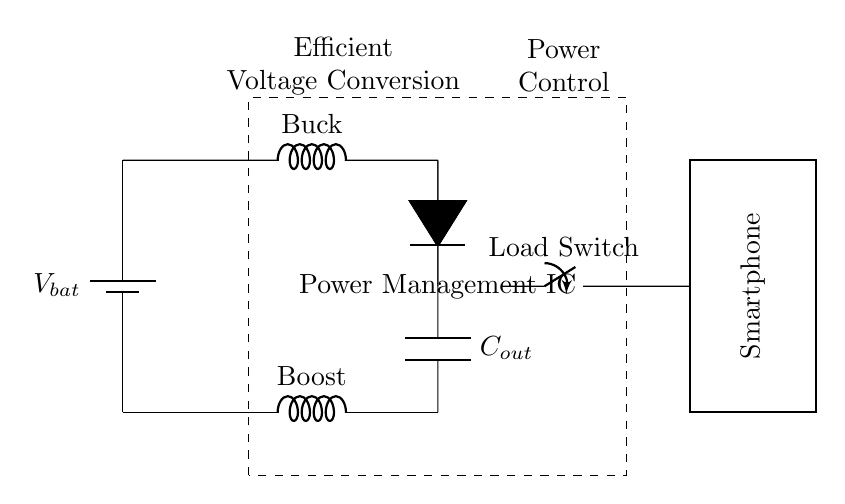What is the function of the Buck converter? The Buck converter is responsible for stepping down the voltage from the battery to a lower voltage suitable for the smartphone's operational requirements. This is indicated by the labeled component in the circuit diagram.
Answer: Stepping down voltage What does the Power Management IC control? The Power Management IC manages the overall power distribution and conversion within the circuit, optimizing battery usage for efficiency and extending battery life during workdays.
Answer: Power distribution How many main types of converters are in the circuit? There are two main types of converters present in the circuit: a Buck converter and a Boost converter, both of which serve different voltage regulation purposes.
Answer: Two What component is directly connected to the smartphone? The load switch is the component directly connected to the smartphone, serving to control the power supplied to the device.
Answer: Load Switch What is the role of the capacitor labeled C_out? The capacitor C_out helps stabilize the output voltage by smoothing fluctuations in the voltage supplied to the load, enhancing overall circuit performance and reliability.
Answer: Stabilization Which direction does current flow from the battery? Current flows from the battery through the Buck converter to the load switch, providing power to the smartphone. The arrows in the diagram help indicate this direction.
Answer: From battery to load What happens when the load switch is closed? When the load switch is closed, it completes the circuit, allowing power to flow from the power management circuit to the smartphone, enabling it to operate.
Answer: Power flows to smartphone 